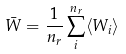Convert formula to latex. <formula><loc_0><loc_0><loc_500><loc_500>\bar { W } = \frac { 1 } { n _ { r } } \sum _ { i } ^ { n _ { r } } \langle W _ { i } \rangle</formula> 